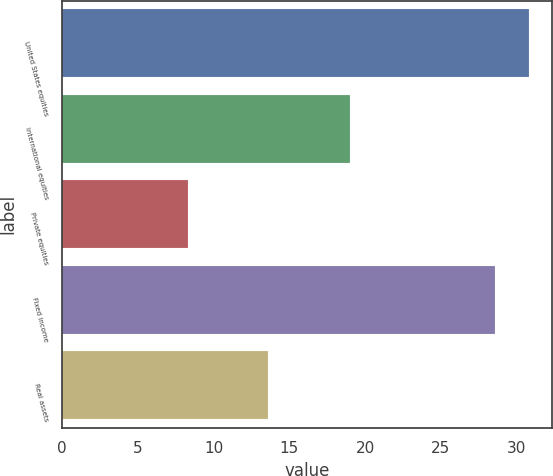<chart> <loc_0><loc_0><loc_500><loc_500><bar_chart><fcel>United States equities<fcel>International equities<fcel>Private equities<fcel>Fixed income<fcel>Real assets<nl><fcel>30.82<fcel>19<fcel>8.3<fcel>28.6<fcel>13.6<nl></chart> 